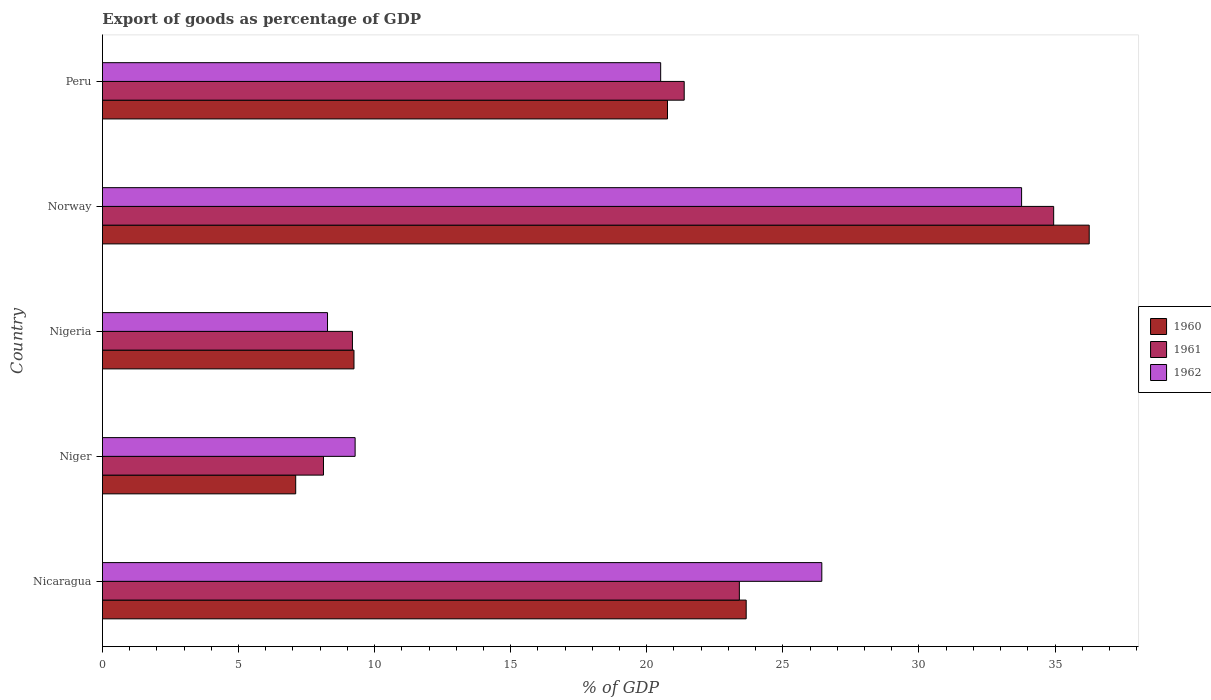How many groups of bars are there?
Offer a very short reply. 5. Are the number of bars per tick equal to the number of legend labels?
Ensure brevity in your answer.  Yes. Are the number of bars on each tick of the Y-axis equal?
Your answer should be very brief. Yes. How many bars are there on the 2nd tick from the bottom?
Your answer should be compact. 3. What is the label of the 3rd group of bars from the top?
Make the answer very short. Nigeria. What is the export of goods as percentage of GDP in 1960 in Nicaragua?
Ensure brevity in your answer.  23.65. Across all countries, what is the maximum export of goods as percentage of GDP in 1961?
Ensure brevity in your answer.  34.95. Across all countries, what is the minimum export of goods as percentage of GDP in 1960?
Your answer should be compact. 7.1. In which country was the export of goods as percentage of GDP in 1962 maximum?
Your answer should be very brief. Norway. In which country was the export of goods as percentage of GDP in 1962 minimum?
Your answer should be compact. Nigeria. What is the total export of goods as percentage of GDP in 1961 in the graph?
Keep it short and to the point. 97.03. What is the difference between the export of goods as percentage of GDP in 1962 in Niger and that in Norway?
Offer a very short reply. -24.49. What is the difference between the export of goods as percentage of GDP in 1961 in Nicaragua and the export of goods as percentage of GDP in 1960 in Norway?
Provide a short and direct response. -12.86. What is the average export of goods as percentage of GDP in 1962 per country?
Offer a terse response. 19.65. What is the difference between the export of goods as percentage of GDP in 1960 and export of goods as percentage of GDP in 1962 in Nigeria?
Your answer should be very brief. 0.97. What is the ratio of the export of goods as percentage of GDP in 1962 in Nigeria to that in Norway?
Provide a short and direct response. 0.24. Is the export of goods as percentage of GDP in 1961 in Niger less than that in Norway?
Offer a very short reply. Yes. What is the difference between the highest and the second highest export of goods as percentage of GDP in 1960?
Provide a succinct answer. 12.6. What is the difference between the highest and the lowest export of goods as percentage of GDP in 1962?
Offer a very short reply. 25.5. In how many countries, is the export of goods as percentage of GDP in 1961 greater than the average export of goods as percentage of GDP in 1961 taken over all countries?
Make the answer very short. 3. Is the sum of the export of goods as percentage of GDP in 1960 in Niger and Peru greater than the maximum export of goods as percentage of GDP in 1962 across all countries?
Your answer should be compact. No. How many bars are there?
Your answer should be compact. 15. Are all the bars in the graph horizontal?
Your answer should be compact. Yes. What is the difference between two consecutive major ticks on the X-axis?
Keep it short and to the point. 5. Does the graph contain any zero values?
Offer a very short reply. No. What is the title of the graph?
Your response must be concise. Export of goods as percentage of GDP. What is the label or title of the X-axis?
Make the answer very short. % of GDP. What is the label or title of the Y-axis?
Your response must be concise. Country. What is the % of GDP of 1960 in Nicaragua?
Give a very brief answer. 23.65. What is the % of GDP in 1961 in Nicaragua?
Make the answer very short. 23.4. What is the % of GDP of 1962 in Nicaragua?
Ensure brevity in your answer.  26.43. What is the % of GDP in 1960 in Niger?
Provide a short and direct response. 7.1. What is the % of GDP of 1961 in Niger?
Provide a short and direct response. 8.12. What is the % of GDP of 1962 in Niger?
Provide a succinct answer. 9.28. What is the % of GDP in 1960 in Nigeria?
Your response must be concise. 9.24. What is the % of GDP in 1961 in Nigeria?
Ensure brevity in your answer.  9.19. What is the % of GDP in 1962 in Nigeria?
Give a very brief answer. 8.27. What is the % of GDP in 1960 in Norway?
Make the answer very short. 36.26. What is the % of GDP in 1961 in Norway?
Your answer should be very brief. 34.95. What is the % of GDP in 1962 in Norway?
Ensure brevity in your answer.  33.77. What is the % of GDP of 1960 in Peru?
Your answer should be compact. 20.76. What is the % of GDP in 1961 in Peru?
Offer a very short reply. 21.38. What is the % of GDP of 1962 in Peru?
Provide a short and direct response. 20.51. Across all countries, what is the maximum % of GDP of 1960?
Keep it short and to the point. 36.26. Across all countries, what is the maximum % of GDP in 1961?
Offer a terse response. 34.95. Across all countries, what is the maximum % of GDP in 1962?
Provide a succinct answer. 33.77. Across all countries, what is the minimum % of GDP in 1960?
Your answer should be compact. 7.1. Across all countries, what is the minimum % of GDP in 1961?
Provide a short and direct response. 8.12. Across all countries, what is the minimum % of GDP in 1962?
Your answer should be compact. 8.27. What is the total % of GDP in 1960 in the graph?
Offer a very short reply. 97.01. What is the total % of GDP of 1961 in the graph?
Provide a succinct answer. 97.03. What is the total % of GDP of 1962 in the graph?
Your answer should be very brief. 98.27. What is the difference between the % of GDP of 1960 in Nicaragua and that in Niger?
Your response must be concise. 16.55. What is the difference between the % of GDP in 1961 in Nicaragua and that in Niger?
Make the answer very short. 15.28. What is the difference between the % of GDP in 1962 in Nicaragua and that in Niger?
Offer a very short reply. 17.15. What is the difference between the % of GDP in 1960 in Nicaragua and that in Nigeria?
Your answer should be compact. 14.41. What is the difference between the % of GDP in 1961 in Nicaragua and that in Nigeria?
Keep it short and to the point. 14.22. What is the difference between the % of GDP of 1962 in Nicaragua and that in Nigeria?
Offer a very short reply. 18.16. What is the difference between the % of GDP of 1960 in Nicaragua and that in Norway?
Make the answer very short. -12.6. What is the difference between the % of GDP in 1961 in Nicaragua and that in Norway?
Your answer should be very brief. -11.55. What is the difference between the % of GDP in 1962 in Nicaragua and that in Norway?
Offer a terse response. -7.34. What is the difference between the % of GDP of 1960 in Nicaragua and that in Peru?
Provide a short and direct response. 2.89. What is the difference between the % of GDP in 1961 in Nicaragua and that in Peru?
Offer a very short reply. 2.03. What is the difference between the % of GDP of 1962 in Nicaragua and that in Peru?
Keep it short and to the point. 5.92. What is the difference between the % of GDP of 1960 in Niger and that in Nigeria?
Your answer should be compact. -2.14. What is the difference between the % of GDP in 1961 in Niger and that in Nigeria?
Provide a short and direct response. -1.06. What is the difference between the % of GDP in 1962 in Niger and that in Nigeria?
Ensure brevity in your answer.  1.01. What is the difference between the % of GDP in 1960 in Niger and that in Norway?
Provide a succinct answer. -29.16. What is the difference between the % of GDP in 1961 in Niger and that in Norway?
Offer a very short reply. -26.83. What is the difference between the % of GDP of 1962 in Niger and that in Norway?
Ensure brevity in your answer.  -24.49. What is the difference between the % of GDP of 1960 in Niger and that in Peru?
Provide a succinct answer. -13.66. What is the difference between the % of GDP in 1961 in Niger and that in Peru?
Give a very brief answer. -13.25. What is the difference between the % of GDP in 1962 in Niger and that in Peru?
Offer a very short reply. -11.23. What is the difference between the % of GDP of 1960 in Nigeria and that in Norway?
Provide a succinct answer. -27.02. What is the difference between the % of GDP in 1961 in Nigeria and that in Norway?
Make the answer very short. -25.77. What is the difference between the % of GDP in 1962 in Nigeria and that in Norway?
Your answer should be very brief. -25.5. What is the difference between the % of GDP of 1960 in Nigeria and that in Peru?
Keep it short and to the point. -11.52. What is the difference between the % of GDP in 1961 in Nigeria and that in Peru?
Provide a succinct answer. -12.19. What is the difference between the % of GDP in 1962 in Nigeria and that in Peru?
Your answer should be very brief. -12.24. What is the difference between the % of GDP in 1960 in Norway and that in Peru?
Offer a terse response. 15.5. What is the difference between the % of GDP in 1961 in Norway and that in Peru?
Your answer should be very brief. 13.58. What is the difference between the % of GDP in 1962 in Norway and that in Peru?
Provide a short and direct response. 13.26. What is the difference between the % of GDP in 1960 in Nicaragua and the % of GDP in 1961 in Niger?
Your answer should be compact. 15.53. What is the difference between the % of GDP in 1960 in Nicaragua and the % of GDP in 1962 in Niger?
Ensure brevity in your answer.  14.37. What is the difference between the % of GDP of 1961 in Nicaragua and the % of GDP of 1962 in Niger?
Your response must be concise. 14.12. What is the difference between the % of GDP of 1960 in Nicaragua and the % of GDP of 1961 in Nigeria?
Your answer should be very brief. 14.47. What is the difference between the % of GDP in 1960 in Nicaragua and the % of GDP in 1962 in Nigeria?
Offer a very short reply. 15.38. What is the difference between the % of GDP in 1961 in Nicaragua and the % of GDP in 1962 in Nigeria?
Provide a succinct answer. 15.13. What is the difference between the % of GDP of 1960 in Nicaragua and the % of GDP of 1961 in Norway?
Provide a succinct answer. -11.3. What is the difference between the % of GDP of 1960 in Nicaragua and the % of GDP of 1962 in Norway?
Your answer should be very brief. -10.12. What is the difference between the % of GDP of 1961 in Nicaragua and the % of GDP of 1962 in Norway?
Ensure brevity in your answer.  -10.37. What is the difference between the % of GDP in 1960 in Nicaragua and the % of GDP in 1961 in Peru?
Ensure brevity in your answer.  2.28. What is the difference between the % of GDP of 1960 in Nicaragua and the % of GDP of 1962 in Peru?
Provide a short and direct response. 3.14. What is the difference between the % of GDP of 1961 in Nicaragua and the % of GDP of 1962 in Peru?
Give a very brief answer. 2.89. What is the difference between the % of GDP of 1960 in Niger and the % of GDP of 1961 in Nigeria?
Provide a short and direct response. -2.08. What is the difference between the % of GDP in 1960 in Niger and the % of GDP in 1962 in Nigeria?
Offer a terse response. -1.17. What is the difference between the % of GDP of 1961 in Niger and the % of GDP of 1962 in Nigeria?
Keep it short and to the point. -0.15. What is the difference between the % of GDP of 1960 in Niger and the % of GDP of 1961 in Norway?
Give a very brief answer. -27.85. What is the difference between the % of GDP of 1960 in Niger and the % of GDP of 1962 in Norway?
Ensure brevity in your answer.  -26.67. What is the difference between the % of GDP in 1961 in Niger and the % of GDP in 1962 in Norway?
Keep it short and to the point. -25.65. What is the difference between the % of GDP of 1960 in Niger and the % of GDP of 1961 in Peru?
Keep it short and to the point. -14.27. What is the difference between the % of GDP of 1960 in Niger and the % of GDP of 1962 in Peru?
Your answer should be compact. -13.41. What is the difference between the % of GDP in 1961 in Niger and the % of GDP in 1962 in Peru?
Make the answer very short. -12.39. What is the difference between the % of GDP in 1960 in Nigeria and the % of GDP in 1961 in Norway?
Ensure brevity in your answer.  -25.71. What is the difference between the % of GDP of 1960 in Nigeria and the % of GDP of 1962 in Norway?
Your answer should be compact. -24.53. What is the difference between the % of GDP of 1961 in Nigeria and the % of GDP of 1962 in Norway?
Offer a terse response. -24.59. What is the difference between the % of GDP of 1960 in Nigeria and the % of GDP of 1961 in Peru?
Give a very brief answer. -12.13. What is the difference between the % of GDP of 1960 in Nigeria and the % of GDP of 1962 in Peru?
Keep it short and to the point. -11.27. What is the difference between the % of GDP of 1961 in Nigeria and the % of GDP of 1962 in Peru?
Make the answer very short. -11.33. What is the difference between the % of GDP in 1960 in Norway and the % of GDP in 1961 in Peru?
Provide a succinct answer. 14.88. What is the difference between the % of GDP in 1960 in Norway and the % of GDP in 1962 in Peru?
Ensure brevity in your answer.  15.75. What is the difference between the % of GDP of 1961 in Norway and the % of GDP of 1962 in Peru?
Provide a short and direct response. 14.44. What is the average % of GDP in 1960 per country?
Give a very brief answer. 19.4. What is the average % of GDP of 1961 per country?
Your answer should be very brief. 19.41. What is the average % of GDP of 1962 per country?
Ensure brevity in your answer.  19.65. What is the difference between the % of GDP of 1960 and % of GDP of 1961 in Nicaragua?
Your answer should be compact. 0.25. What is the difference between the % of GDP of 1960 and % of GDP of 1962 in Nicaragua?
Give a very brief answer. -2.78. What is the difference between the % of GDP of 1961 and % of GDP of 1962 in Nicaragua?
Your answer should be very brief. -3.03. What is the difference between the % of GDP of 1960 and % of GDP of 1961 in Niger?
Provide a short and direct response. -1.02. What is the difference between the % of GDP in 1960 and % of GDP in 1962 in Niger?
Provide a short and direct response. -2.18. What is the difference between the % of GDP in 1961 and % of GDP in 1962 in Niger?
Ensure brevity in your answer.  -1.16. What is the difference between the % of GDP of 1960 and % of GDP of 1961 in Nigeria?
Give a very brief answer. 0.06. What is the difference between the % of GDP of 1960 and % of GDP of 1962 in Nigeria?
Your response must be concise. 0.97. What is the difference between the % of GDP in 1961 and % of GDP in 1962 in Nigeria?
Your answer should be very brief. 0.92. What is the difference between the % of GDP in 1960 and % of GDP in 1961 in Norway?
Your answer should be compact. 1.31. What is the difference between the % of GDP of 1960 and % of GDP of 1962 in Norway?
Ensure brevity in your answer.  2.48. What is the difference between the % of GDP in 1961 and % of GDP in 1962 in Norway?
Offer a terse response. 1.18. What is the difference between the % of GDP in 1960 and % of GDP in 1961 in Peru?
Your answer should be very brief. -0.61. What is the difference between the % of GDP in 1960 and % of GDP in 1962 in Peru?
Give a very brief answer. 0.25. What is the difference between the % of GDP in 1961 and % of GDP in 1962 in Peru?
Your answer should be compact. 0.86. What is the ratio of the % of GDP in 1960 in Nicaragua to that in Niger?
Ensure brevity in your answer.  3.33. What is the ratio of the % of GDP in 1961 in Nicaragua to that in Niger?
Keep it short and to the point. 2.88. What is the ratio of the % of GDP in 1962 in Nicaragua to that in Niger?
Your response must be concise. 2.85. What is the ratio of the % of GDP in 1960 in Nicaragua to that in Nigeria?
Give a very brief answer. 2.56. What is the ratio of the % of GDP of 1961 in Nicaragua to that in Nigeria?
Make the answer very short. 2.55. What is the ratio of the % of GDP in 1962 in Nicaragua to that in Nigeria?
Provide a short and direct response. 3.2. What is the ratio of the % of GDP in 1960 in Nicaragua to that in Norway?
Ensure brevity in your answer.  0.65. What is the ratio of the % of GDP of 1961 in Nicaragua to that in Norway?
Give a very brief answer. 0.67. What is the ratio of the % of GDP in 1962 in Nicaragua to that in Norway?
Give a very brief answer. 0.78. What is the ratio of the % of GDP of 1960 in Nicaragua to that in Peru?
Offer a terse response. 1.14. What is the ratio of the % of GDP of 1961 in Nicaragua to that in Peru?
Give a very brief answer. 1.09. What is the ratio of the % of GDP of 1962 in Nicaragua to that in Peru?
Make the answer very short. 1.29. What is the ratio of the % of GDP in 1960 in Niger to that in Nigeria?
Make the answer very short. 0.77. What is the ratio of the % of GDP of 1961 in Niger to that in Nigeria?
Give a very brief answer. 0.88. What is the ratio of the % of GDP of 1962 in Niger to that in Nigeria?
Your response must be concise. 1.12. What is the ratio of the % of GDP of 1960 in Niger to that in Norway?
Your answer should be very brief. 0.2. What is the ratio of the % of GDP in 1961 in Niger to that in Norway?
Give a very brief answer. 0.23. What is the ratio of the % of GDP in 1962 in Niger to that in Norway?
Make the answer very short. 0.27. What is the ratio of the % of GDP of 1960 in Niger to that in Peru?
Provide a short and direct response. 0.34. What is the ratio of the % of GDP of 1961 in Niger to that in Peru?
Keep it short and to the point. 0.38. What is the ratio of the % of GDP of 1962 in Niger to that in Peru?
Keep it short and to the point. 0.45. What is the ratio of the % of GDP of 1960 in Nigeria to that in Norway?
Keep it short and to the point. 0.25. What is the ratio of the % of GDP of 1961 in Nigeria to that in Norway?
Offer a terse response. 0.26. What is the ratio of the % of GDP of 1962 in Nigeria to that in Norway?
Your answer should be very brief. 0.24. What is the ratio of the % of GDP in 1960 in Nigeria to that in Peru?
Keep it short and to the point. 0.45. What is the ratio of the % of GDP of 1961 in Nigeria to that in Peru?
Give a very brief answer. 0.43. What is the ratio of the % of GDP in 1962 in Nigeria to that in Peru?
Your answer should be compact. 0.4. What is the ratio of the % of GDP in 1960 in Norway to that in Peru?
Make the answer very short. 1.75. What is the ratio of the % of GDP in 1961 in Norway to that in Peru?
Provide a short and direct response. 1.64. What is the ratio of the % of GDP of 1962 in Norway to that in Peru?
Provide a short and direct response. 1.65. What is the difference between the highest and the second highest % of GDP of 1960?
Your answer should be very brief. 12.6. What is the difference between the highest and the second highest % of GDP in 1961?
Your response must be concise. 11.55. What is the difference between the highest and the second highest % of GDP of 1962?
Offer a very short reply. 7.34. What is the difference between the highest and the lowest % of GDP of 1960?
Your response must be concise. 29.16. What is the difference between the highest and the lowest % of GDP in 1961?
Offer a terse response. 26.83. What is the difference between the highest and the lowest % of GDP in 1962?
Give a very brief answer. 25.5. 